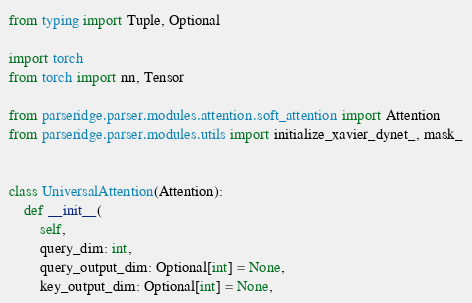<code> <loc_0><loc_0><loc_500><loc_500><_Python_>from typing import Tuple, Optional

import torch
from torch import nn, Tensor

from parseridge.parser.modules.attention.soft_attention import Attention
from parseridge.parser.modules.utils import initialize_xavier_dynet_, mask_


class UniversalAttention(Attention):
    def __init__(
        self,
        query_dim: int,
        query_output_dim: Optional[int] = None,
        key_output_dim: Optional[int] = None,</code> 